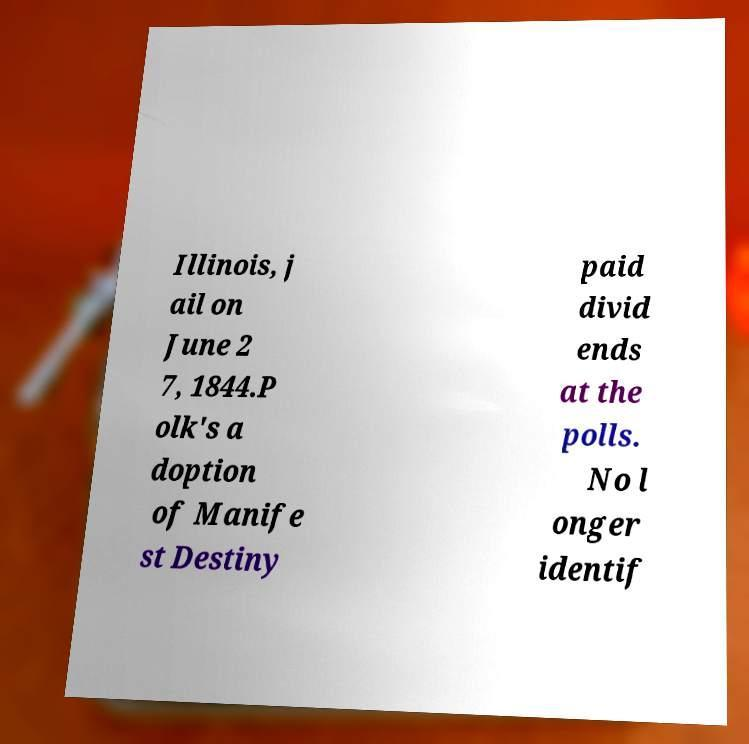There's text embedded in this image that I need extracted. Can you transcribe it verbatim? Illinois, j ail on June 2 7, 1844.P olk's a doption of Manife st Destiny paid divid ends at the polls. No l onger identif 